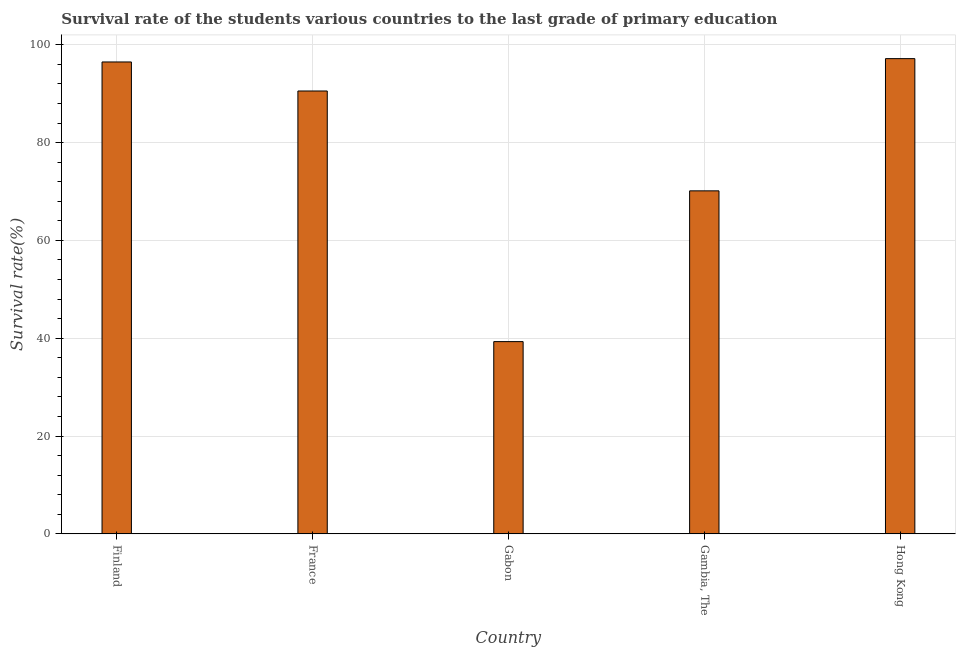What is the title of the graph?
Offer a very short reply. Survival rate of the students various countries to the last grade of primary education. What is the label or title of the Y-axis?
Ensure brevity in your answer.  Survival rate(%). What is the survival rate in primary education in Gabon?
Make the answer very short. 39.31. Across all countries, what is the maximum survival rate in primary education?
Provide a short and direct response. 97.16. Across all countries, what is the minimum survival rate in primary education?
Offer a terse response. 39.31. In which country was the survival rate in primary education maximum?
Your answer should be compact. Hong Kong. In which country was the survival rate in primary education minimum?
Your answer should be very brief. Gabon. What is the sum of the survival rate in primary education?
Provide a succinct answer. 393.63. What is the difference between the survival rate in primary education in Gabon and Hong Kong?
Give a very brief answer. -57.86. What is the average survival rate in primary education per country?
Your answer should be compact. 78.73. What is the median survival rate in primary education?
Provide a short and direct response. 90.55. In how many countries, is the survival rate in primary education greater than 48 %?
Keep it short and to the point. 4. What is the ratio of the survival rate in primary education in France to that in Gambia, The?
Provide a succinct answer. 1.29. Is the survival rate in primary education in Finland less than that in Hong Kong?
Your answer should be compact. Yes. Is the difference between the survival rate in primary education in Finland and Gabon greater than the difference between any two countries?
Your answer should be very brief. No. What is the difference between the highest and the second highest survival rate in primary education?
Your response must be concise. 0.68. What is the difference between the highest and the lowest survival rate in primary education?
Give a very brief answer. 57.86. How many bars are there?
Give a very brief answer. 5. Are all the bars in the graph horizontal?
Your answer should be very brief. No. What is the difference between two consecutive major ticks on the Y-axis?
Ensure brevity in your answer.  20. Are the values on the major ticks of Y-axis written in scientific E-notation?
Provide a succinct answer. No. What is the Survival rate(%) of Finland?
Keep it short and to the point. 96.48. What is the Survival rate(%) of France?
Offer a very short reply. 90.55. What is the Survival rate(%) in Gabon?
Give a very brief answer. 39.31. What is the Survival rate(%) of Gambia, The?
Offer a terse response. 70.13. What is the Survival rate(%) of Hong Kong?
Offer a very short reply. 97.16. What is the difference between the Survival rate(%) in Finland and France?
Make the answer very short. 5.93. What is the difference between the Survival rate(%) in Finland and Gabon?
Provide a succinct answer. 57.18. What is the difference between the Survival rate(%) in Finland and Gambia, The?
Ensure brevity in your answer.  26.35. What is the difference between the Survival rate(%) in Finland and Hong Kong?
Your response must be concise. -0.68. What is the difference between the Survival rate(%) in France and Gabon?
Offer a very short reply. 51.24. What is the difference between the Survival rate(%) in France and Gambia, The?
Provide a short and direct response. 20.42. What is the difference between the Survival rate(%) in France and Hong Kong?
Give a very brief answer. -6.61. What is the difference between the Survival rate(%) in Gabon and Gambia, The?
Your answer should be very brief. -30.82. What is the difference between the Survival rate(%) in Gabon and Hong Kong?
Your response must be concise. -57.86. What is the difference between the Survival rate(%) in Gambia, The and Hong Kong?
Your answer should be very brief. -27.03. What is the ratio of the Survival rate(%) in Finland to that in France?
Make the answer very short. 1.07. What is the ratio of the Survival rate(%) in Finland to that in Gabon?
Ensure brevity in your answer.  2.46. What is the ratio of the Survival rate(%) in Finland to that in Gambia, The?
Your response must be concise. 1.38. What is the ratio of the Survival rate(%) in Finland to that in Hong Kong?
Offer a terse response. 0.99. What is the ratio of the Survival rate(%) in France to that in Gabon?
Ensure brevity in your answer.  2.3. What is the ratio of the Survival rate(%) in France to that in Gambia, The?
Give a very brief answer. 1.29. What is the ratio of the Survival rate(%) in France to that in Hong Kong?
Ensure brevity in your answer.  0.93. What is the ratio of the Survival rate(%) in Gabon to that in Gambia, The?
Ensure brevity in your answer.  0.56. What is the ratio of the Survival rate(%) in Gabon to that in Hong Kong?
Your response must be concise. 0.41. What is the ratio of the Survival rate(%) in Gambia, The to that in Hong Kong?
Your response must be concise. 0.72. 